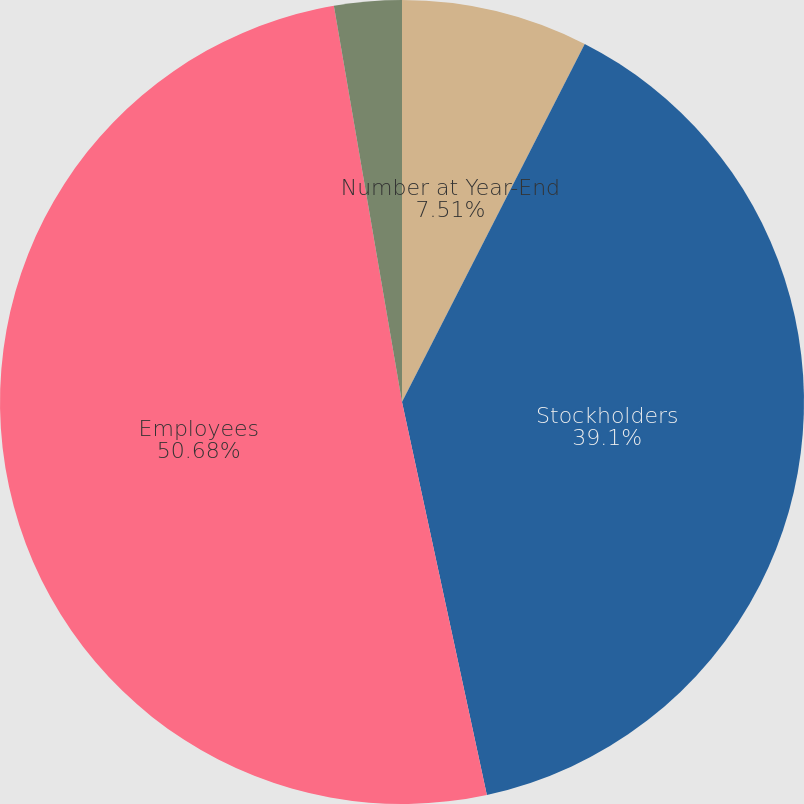<chart> <loc_0><loc_0><loc_500><loc_500><pie_chart><fcel>Number at Year-End<fcel>Stockholders<fcel>Employees<fcel>Offices<nl><fcel>7.51%<fcel>39.1%<fcel>50.67%<fcel>2.71%<nl></chart> 